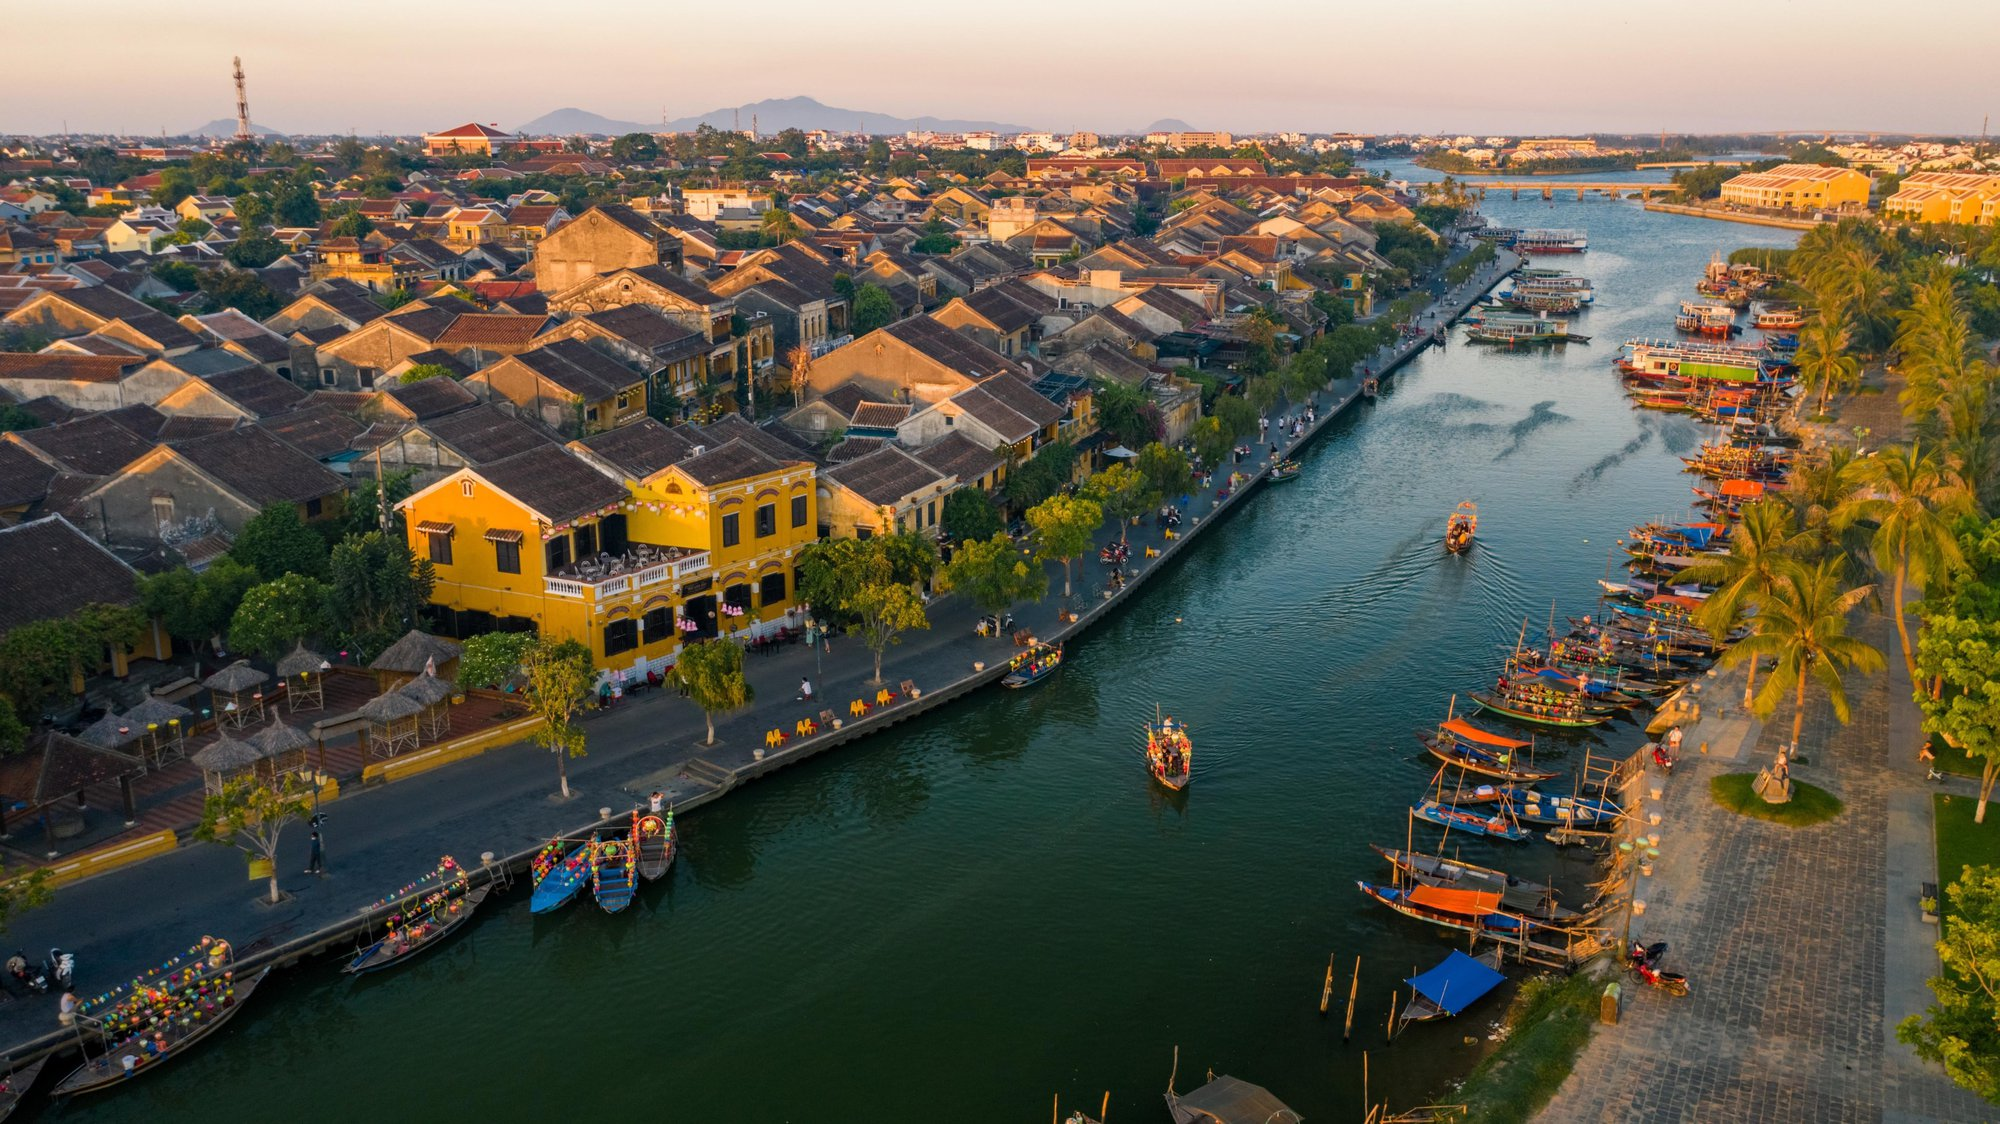Describe the mood and atmosphere of the riverside community at sunset. At sunset, the riverside community exudes a tranquil yet vibrant atmosphere. The sky takes on hues of orange, pink, and gold, casting a warm glow over the water and the town. The boats, adorned with colorful lanterns, begin to light up, reflecting softly on the river's surface. The streets along the riverbank become bustling with activity as locals and tourists alike come out to enjoy the evening. You can hear the sounds of laughter, conversations, and music floating through the air. Street vendors set up their stalls, selling a variety of local delicacies and crafts, adding to the lively yet relaxed ambiance. The mood is a mix of calm reflection and joyful celebration, as the community comes together to appreciate the beauty of the day’s end and the promise of the night’s festivities. 